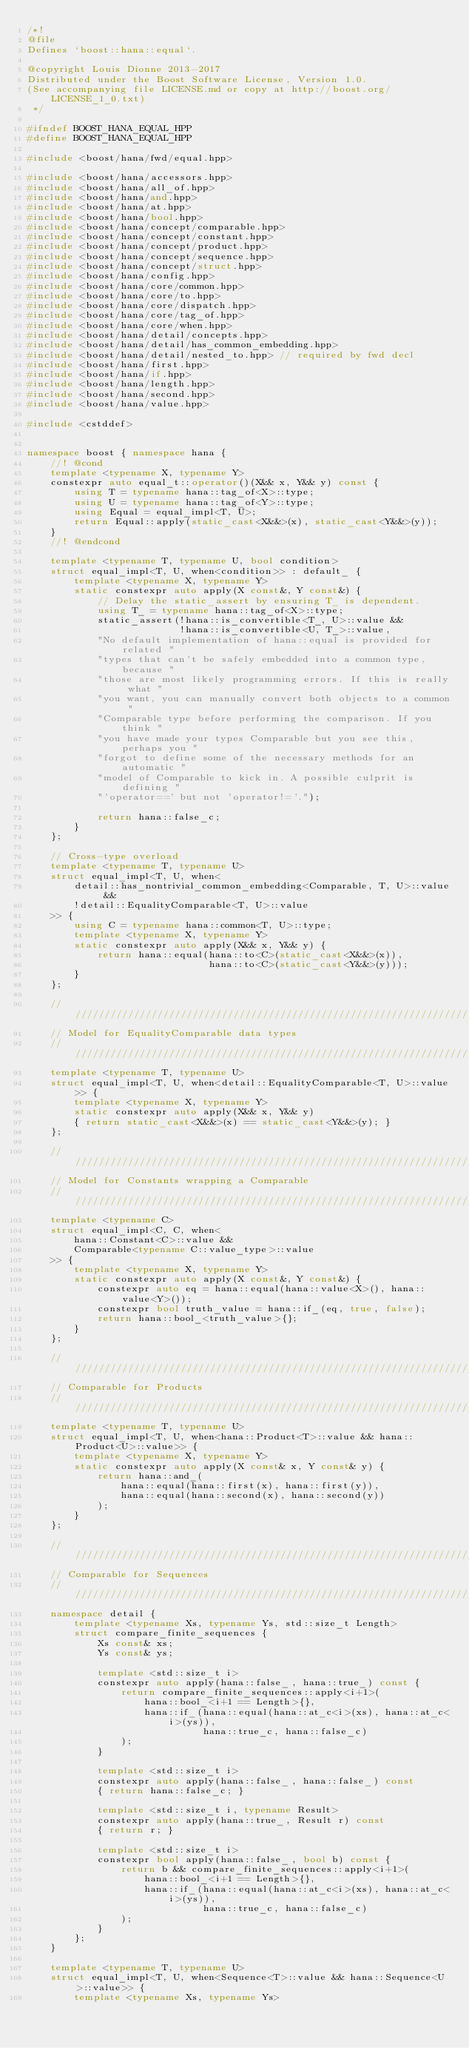Convert code to text. <code><loc_0><loc_0><loc_500><loc_500><_C++_>/*!
@file
Defines `boost::hana::equal`.

@copyright Louis Dionne 2013-2017
Distributed under the Boost Software License, Version 1.0.
(See accompanying file LICENSE.md or copy at http://boost.org/LICENSE_1_0.txt)
 */

#ifndef BOOST_HANA_EQUAL_HPP
#define BOOST_HANA_EQUAL_HPP

#include <boost/hana/fwd/equal.hpp>

#include <boost/hana/accessors.hpp>
#include <boost/hana/all_of.hpp>
#include <boost/hana/and.hpp>
#include <boost/hana/at.hpp>
#include <boost/hana/bool.hpp>
#include <boost/hana/concept/comparable.hpp>
#include <boost/hana/concept/constant.hpp>
#include <boost/hana/concept/product.hpp>
#include <boost/hana/concept/sequence.hpp>
#include <boost/hana/concept/struct.hpp>
#include <boost/hana/config.hpp>
#include <boost/hana/core/common.hpp>
#include <boost/hana/core/to.hpp>
#include <boost/hana/core/dispatch.hpp>
#include <boost/hana/core/tag_of.hpp>
#include <boost/hana/core/when.hpp>
#include <boost/hana/detail/concepts.hpp>
#include <boost/hana/detail/has_common_embedding.hpp>
#include <boost/hana/detail/nested_to.hpp> // required by fwd decl
#include <boost/hana/first.hpp>
#include <boost/hana/if.hpp>
#include <boost/hana/length.hpp>
#include <boost/hana/second.hpp>
#include <boost/hana/value.hpp>

#include <cstddef>


namespace boost { namespace hana {
    //! @cond
    template <typename X, typename Y>
    constexpr auto equal_t::operator()(X&& x, Y&& y) const {
        using T = typename hana::tag_of<X>::type;
        using U = typename hana::tag_of<Y>::type;
        using Equal = equal_impl<T, U>;
        return Equal::apply(static_cast<X&&>(x), static_cast<Y&&>(y));
    }
    //! @endcond

    template <typename T, typename U, bool condition>
    struct equal_impl<T, U, when<condition>> : default_ {
        template <typename X, typename Y>
        static constexpr auto apply(X const&, Y const&) {
            // Delay the static_assert by ensuring T_ is dependent.
            using T_ = typename hana::tag_of<X>::type;
            static_assert(!hana::is_convertible<T_, U>::value &&
                          !hana::is_convertible<U, T_>::value,
            "No default implementation of hana::equal is provided for related "
            "types that can't be safely embedded into a common type, because "
            "those are most likely programming errors. If this is really what "
            "you want, you can manually convert both objects to a common "
            "Comparable type before performing the comparison. If you think "
            "you have made your types Comparable but you see this, perhaps you "
            "forgot to define some of the necessary methods for an automatic "
            "model of Comparable to kick in. A possible culprit is defining "
            "'operator==' but not 'operator!='.");

            return hana::false_c;
        }
    };

    // Cross-type overload
    template <typename T, typename U>
    struct equal_impl<T, U, when<
        detail::has_nontrivial_common_embedding<Comparable, T, U>::value &&
        !detail::EqualityComparable<T, U>::value
    >> {
        using C = typename hana::common<T, U>::type;
        template <typename X, typename Y>
        static constexpr auto apply(X&& x, Y&& y) {
            return hana::equal(hana::to<C>(static_cast<X&&>(x)),
                               hana::to<C>(static_cast<Y&&>(y)));
        }
    };

    //////////////////////////////////////////////////////////////////////////
    // Model for EqualityComparable data types
    //////////////////////////////////////////////////////////////////////////
    template <typename T, typename U>
    struct equal_impl<T, U, when<detail::EqualityComparable<T, U>::value>> {
        template <typename X, typename Y>
        static constexpr auto apply(X&& x, Y&& y)
        { return static_cast<X&&>(x) == static_cast<Y&&>(y); }
    };

    //////////////////////////////////////////////////////////////////////////
    // Model for Constants wrapping a Comparable
    //////////////////////////////////////////////////////////////////////////
    template <typename C>
    struct equal_impl<C, C, when<
        hana::Constant<C>::value &&
        Comparable<typename C::value_type>::value
    >> {
        template <typename X, typename Y>
        static constexpr auto apply(X const&, Y const&) {
            constexpr auto eq = hana::equal(hana::value<X>(), hana::value<Y>());
            constexpr bool truth_value = hana::if_(eq, true, false);
            return hana::bool_<truth_value>{};
        }
    };

    //////////////////////////////////////////////////////////////////////////
    // Comparable for Products
    //////////////////////////////////////////////////////////////////////////
    template <typename T, typename U>
    struct equal_impl<T, U, when<hana::Product<T>::value && hana::Product<U>::value>> {
        template <typename X, typename Y>
        static constexpr auto apply(X const& x, Y const& y) {
            return hana::and_(
                hana::equal(hana::first(x), hana::first(y)),
                hana::equal(hana::second(x), hana::second(y))
            );
        }
    };

    //////////////////////////////////////////////////////////////////////////
    // Comparable for Sequences
    //////////////////////////////////////////////////////////////////////////
    namespace detail {
        template <typename Xs, typename Ys, std::size_t Length>
        struct compare_finite_sequences {
            Xs const& xs;
            Ys const& ys;

            template <std::size_t i>
            constexpr auto apply(hana::false_, hana::true_) const {
                return compare_finite_sequences::apply<i+1>(
                    hana::bool_<i+1 == Length>{},
                    hana::if_(hana::equal(hana::at_c<i>(xs), hana::at_c<i>(ys)),
                              hana::true_c, hana::false_c)
                );
            }

            template <std::size_t i>
            constexpr auto apply(hana::false_, hana::false_) const
            { return hana::false_c; }

            template <std::size_t i, typename Result>
            constexpr auto apply(hana::true_, Result r) const
            { return r; }

            template <std::size_t i>
            constexpr bool apply(hana::false_, bool b) const {
                return b && compare_finite_sequences::apply<i+1>(
                    hana::bool_<i+1 == Length>{},
                    hana::if_(hana::equal(hana::at_c<i>(xs), hana::at_c<i>(ys)),
                              hana::true_c, hana::false_c)
                );
            }
        };
    }

    template <typename T, typename U>
    struct equal_impl<T, U, when<Sequence<T>::value && hana::Sequence<U>::value>> {
        template <typename Xs, typename Ys></code> 